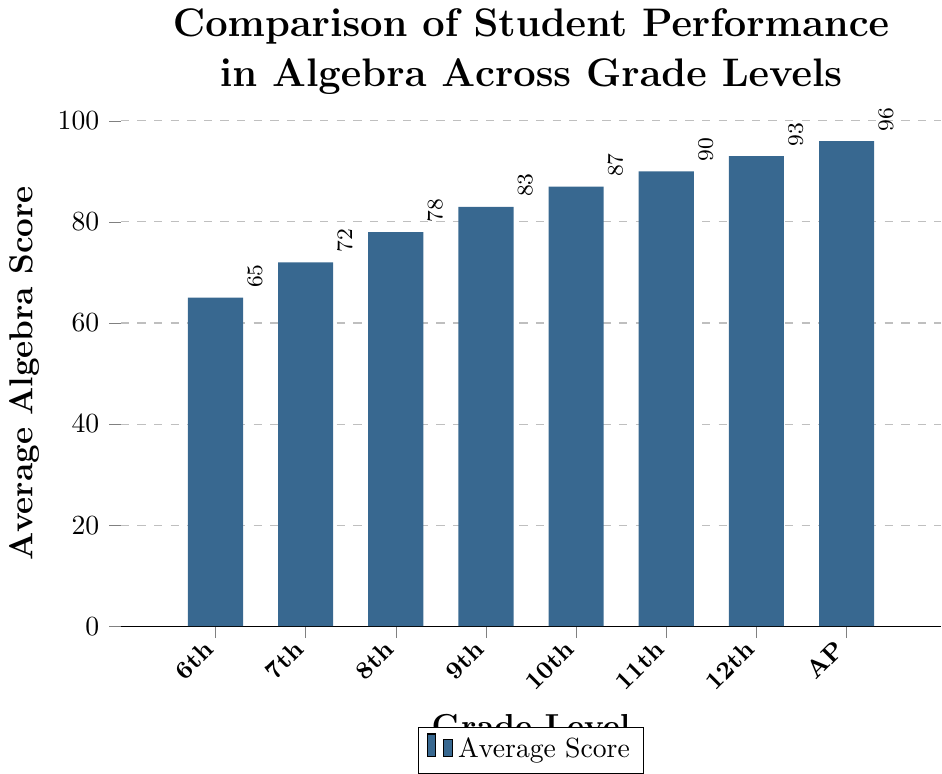Which grade level has the highest average algebra score? The bar representing the "Advanced Placement" level is the tallest among all, indicating the highest average algebra score.
Answer: Advanced Placement What is the average algebra score difference between 6th Grade and 10th Grade? The average score for 6th Grade is 65 and for 10th Grade is 87. Subtracting 65 from 87 gives 22.
Answer: 22 How does the average algebra score change from 8th Grade to 12th Grade? The average algebra score for 8th Grade is 78, and for 12th Grade is 93. Subtracting 78 from 93 gives an increase of 15 points.
Answer: Increase of 15 points Which two consecutive grade levels show the largest increase in average algebra scores? Comparing consecutive grade levels: 
- 6th to 7th: 72 - 65 = 7
- 7th to 8th: 78 - 72 = 6
- 8th to 9th: 83 - 78 = 5
- 9th to 10th: 87 - 83 = 4
- 10th to 11th: 90 - 87 = 3
- 11th to 12th: 93 - 90 = 3
- 12th to AP: 96 - 93 = 3
The largest score increase is between 6th and 7th Grade (7 points).
Answer: 6th to 7th Grade What is the median average algebra score across all grade levels and Advanced Placement? The scores in ascending order are: 65, 72, 78, 83, 87, 90, 93, 96. The median is the average of the two middle scores, (83 + 87)/2 = 85.
Answer: 85 By how much does the average score of 11th Grade exceed that of 9th Grade? The 11th Grade average score is 90, and the 9th Grade average score is 83. Subtracting 83 from 90 gives 7.
Answer: 7 What is the sum of the average algebra scores of 7th Grade and Advanced Placement? The average scores are 72 for 7th Grade and 96 for Advanced Placement. Adding these together gives 72 + 96 = 168.
Answer: 168 Which grade level marks the start of an average algebra score of 80 or above? The 8th Grade has an average score of 78, and the 9th Grade has an average score of 83. Thus, the 9th Grade marks the start of an average score of 80 or above.
Answer: 9th Grade 